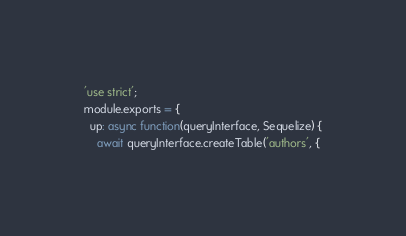Convert code to text. <code><loc_0><loc_0><loc_500><loc_500><_JavaScript_>'use strict';
module.exports = {
  up: async function(queryInterface, Sequelize) {
    await queryInterface.createTable('authors', {</code> 